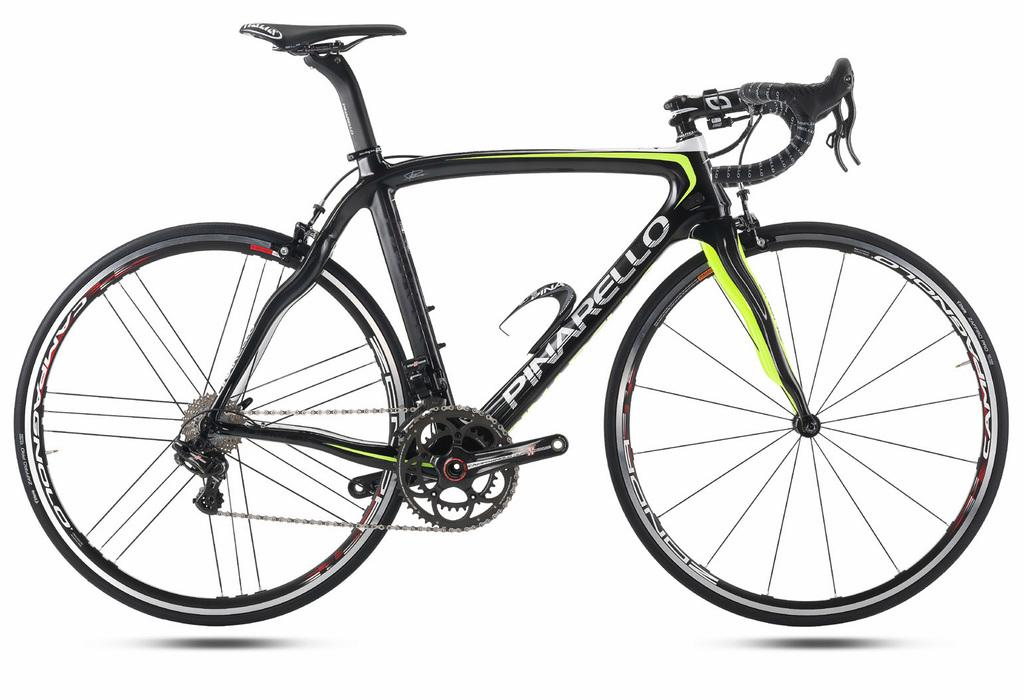What is the main subject of the image? The main subject of the image is a picture of a bicycle. Where is the bicycle located in the image? The bicycle is in the middle of the image. What type of ground can be seen beneath the bicycle in the image? There is no ground visible in the image, as it is a picture of a bicycle and not a photograph of an actual bicycle in a specific location. 